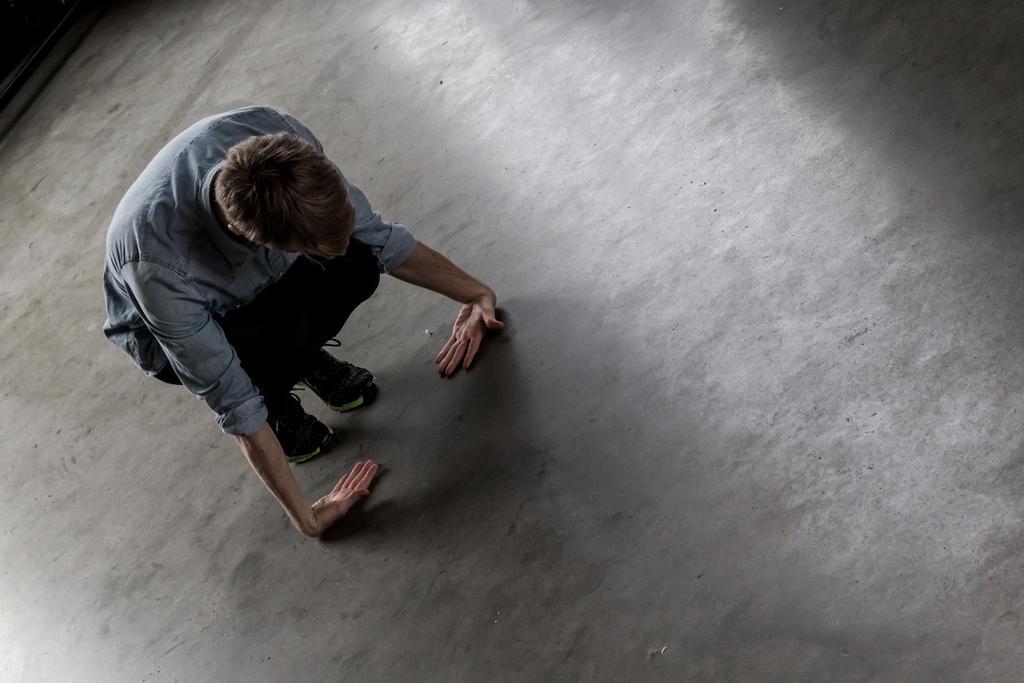In one or two sentences, can you explain what this image depicts? In this picture I can see there is a person sitting in the squatting position and he placed his hands on the floor. 